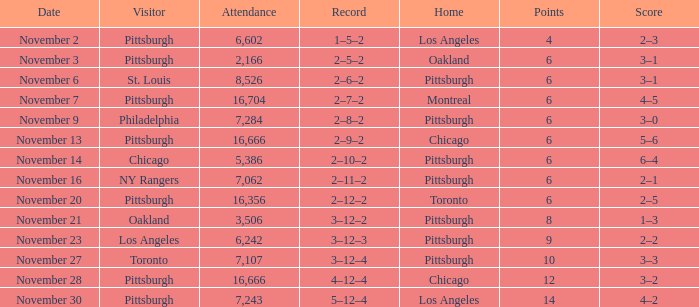What is the lowest amount of points of the game with toronto as the home team? 6.0. 